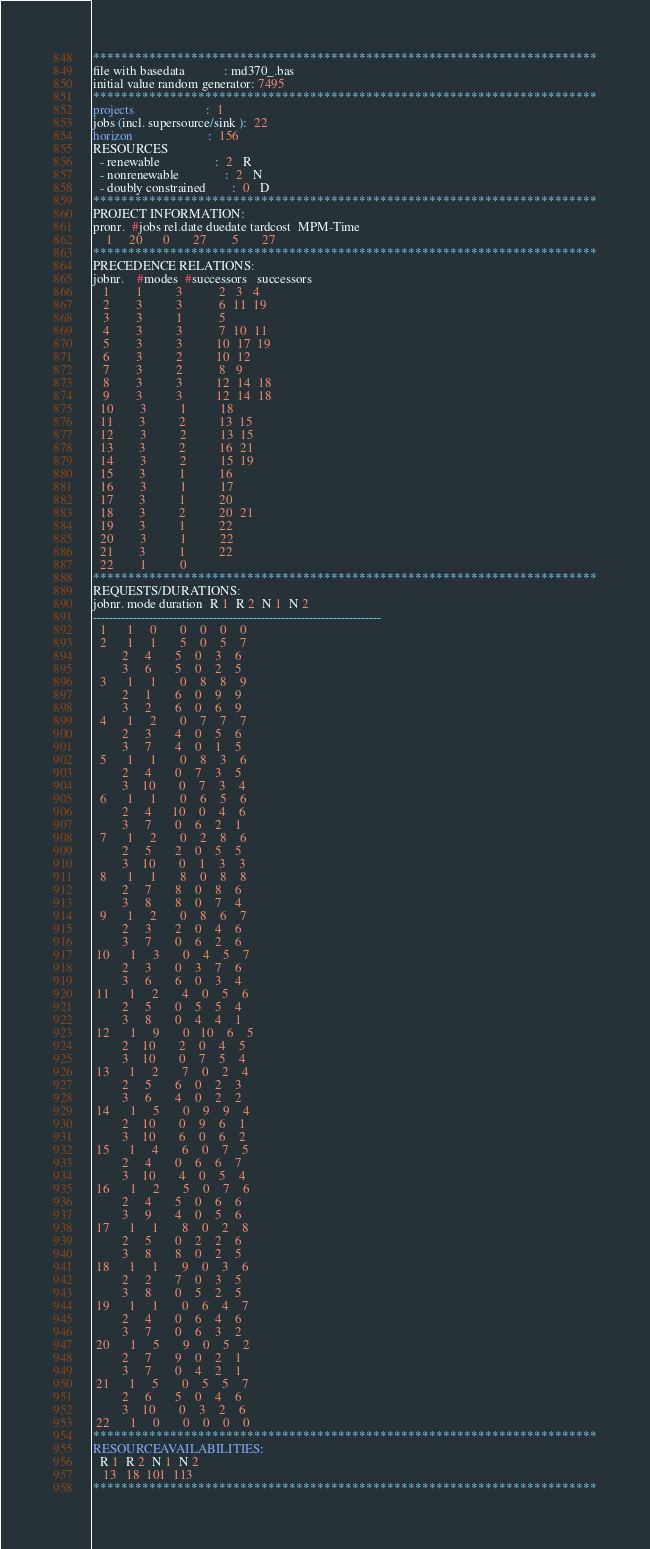Convert code to text. <code><loc_0><loc_0><loc_500><loc_500><_ObjectiveC_>************************************************************************
file with basedata            : md370_.bas
initial value random generator: 7495
************************************************************************
projects                      :  1
jobs (incl. supersource/sink ):  22
horizon                       :  156
RESOURCES
  - renewable                 :  2   R
  - nonrenewable              :  2   N
  - doubly constrained        :  0   D
************************************************************************
PROJECT INFORMATION:
pronr.  #jobs rel.date duedate tardcost  MPM-Time
    1     20      0       27        5       27
************************************************************************
PRECEDENCE RELATIONS:
jobnr.    #modes  #successors   successors
   1        1          3           2   3   4
   2        3          3           6  11  19
   3        3          1           5
   4        3          3           7  10  11
   5        3          3          10  17  19
   6        3          2          10  12
   7        3          2           8   9
   8        3          3          12  14  18
   9        3          3          12  14  18
  10        3          1          18
  11        3          2          13  15
  12        3          2          13  15
  13        3          2          16  21
  14        3          2          15  19
  15        3          1          16
  16        3          1          17
  17        3          1          20
  18        3          2          20  21
  19        3          1          22
  20        3          1          22
  21        3          1          22
  22        1          0        
************************************************************************
REQUESTS/DURATIONS:
jobnr. mode duration  R 1  R 2  N 1  N 2
------------------------------------------------------------------------
  1      1     0       0    0    0    0
  2      1     1       5    0    5    7
         2     4       5    0    3    6
         3     6       5    0    2    5
  3      1     1       0    8    8    9
         2     1       6    0    9    9
         3     2       6    0    6    9
  4      1     2       0    7    7    7
         2     3       4    0    5    6
         3     7       4    0    1    5
  5      1     1       0    8    3    6
         2     4       0    7    3    5
         3    10       0    7    3    4
  6      1     1       0    6    5    6
         2     4      10    0    4    6
         3     7       0    6    2    1
  7      1     2       0    2    8    6
         2     5       2    0    5    5
         3    10       0    1    3    3
  8      1     1       8    0    8    8
         2     7       8    0    8    6
         3     8       8    0    7    4
  9      1     2       0    8    6    7
         2     3       2    0    4    6
         3     7       0    6    2    6
 10      1     3       0    4    5    7
         2     3       0    3    7    6
         3     6       6    0    3    4
 11      1     2       4    0    5    6
         2     5       0    5    5    4
         3     8       0    4    4    1
 12      1     9       0   10    6    5
         2    10       2    0    4    5
         3    10       0    7    5    4
 13      1     2       7    0    2    4
         2     5       6    0    2    3
         3     6       4    0    2    2
 14      1     5       0    9    9    4
         2    10       0    9    6    1
         3    10       6    0    6    2
 15      1     4       6    0    7    5
         2     4       0    6    6    7
         3    10       4    0    5    4
 16      1     2       5    0    7    6
         2     4       5    0    6    6
         3     9       4    0    5    6
 17      1     1       8    0    2    8
         2     5       0    2    2    6
         3     8       8    0    2    5
 18      1     1       9    0    3    6
         2     2       7    0    3    5
         3     8       0    5    2    5
 19      1     1       0    6    4    7
         2     4       0    6    4    6
         3     7       0    6    3    2
 20      1     5       9    0    5    2
         2     7       9    0    2    1
         3     7       0    4    2    1
 21      1     5       0    5    5    7
         2     6       5    0    4    6
         3    10       0    3    2    6
 22      1     0       0    0    0    0
************************************************************************
RESOURCEAVAILABILITIES:
  R 1  R 2  N 1  N 2
   13   18  101  113
************************************************************************
</code> 